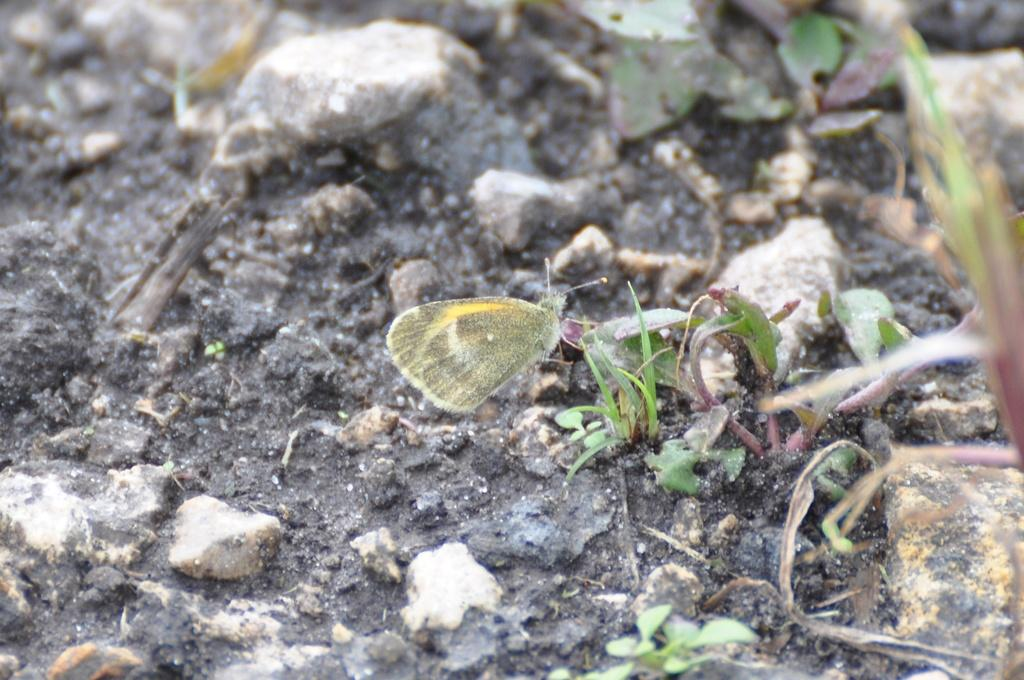What type of creature can be seen in the image? There is a butterfly in the image. What is located at the bottom of the image? There is soil at the bottom of the image. What other objects can be seen in the image? There are stones and leaves present in the image. What type of activity is the butterfly participating in on the desk? There is no desk present in the image, and the butterfly is not participating in any activity. 